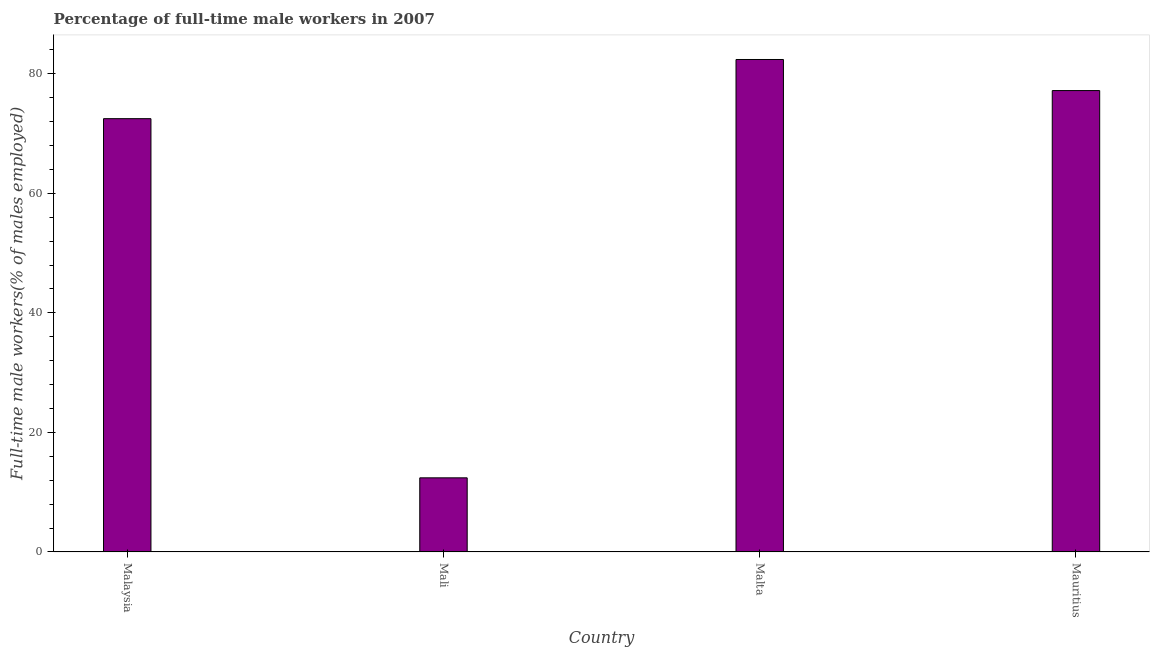Does the graph contain grids?
Give a very brief answer. No. What is the title of the graph?
Give a very brief answer. Percentage of full-time male workers in 2007. What is the label or title of the Y-axis?
Make the answer very short. Full-time male workers(% of males employed). What is the percentage of full-time male workers in Mauritius?
Offer a very short reply. 77.2. Across all countries, what is the maximum percentage of full-time male workers?
Offer a terse response. 82.4. Across all countries, what is the minimum percentage of full-time male workers?
Ensure brevity in your answer.  12.4. In which country was the percentage of full-time male workers maximum?
Make the answer very short. Malta. In which country was the percentage of full-time male workers minimum?
Your answer should be compact. Mali. What is the sum of the percentage of full-time male workers?
Your response must be concise. 244.5. What is the difference between the percentage of full-time male workers in Malaysia and Mauritius?
Keep it short and to the point. -4.7. What is the average percentage of full-time male workers per country?
Offer a terse response. 61.12. What is the median percentage of full-time male workers?
Ensure brevity in your answer.  74.85. In how many countries, is the percentage of full-time male workers greater than 80 %?
Offer a terse response. 1. Is the difference between the percentage of full-time male workers in Mali and Malta greater than the difference between any two countries?
Your answer should be very brief. Yes. What is the difference between the highest and the second highest percentage of full-time male workers?
Ensure brevity in your answer.  5.2. In how many countries, is the percentage of full-time male workers greater than the average percentage of full-time male workers taken over all countries?
Provide a short and direct response. 3. How many bars are there?
Make the answer very short. 4. How many countries are there in the graph?
Offer a very short reply. 4. Are the values on the major ticks of Y-axis written in scientific E-notation?
Keep it short and to the point. No. What is the Full-time male workers(% of males employed) in Malaysia?
Offer a very short reply. 72.5. What is the Full-time male workers(% of males employed) in Mali?
Provide a short and direct response. 12.4. What is the Full-time male workers(% of males employed) in Malta?
Provide a short and direct response. 82.4. What is the Full-time male workers(% of males employed) of Mauritius?
Offer a terse response. 77.2. What is the difference between the Full-time male workers(% of males employed) in Malaysia and Mali?
Your response must be concise. 60.1. What is the difference between the Full-time male workers(% of males employed) in Mali and Malta?
Your answer should be compact. -70. What is the difference between the Full-time male workers(% of males employed) in Mali and Mauritius?
Offer a very short reply. -64.8. What is the ratio of the Full-time male workers(% of males employed) in Malaysia to that in Mali?
Offer a very short reply. 5.85. What is the ratio of the Full-time male workers(% of males employed) in Malaysia to that in Mauritius?
Make the answer very short. 0.94. What is the ratio of the Full-time male workers(% of males employed) in Mali to that in Mauritius?
Your answer should be very brief. 0.16. What is the ratio of the Full-time male workers(% of males employed) in Malta to that in Mauritius?
Ensure brevity in your answer.  1.07. 